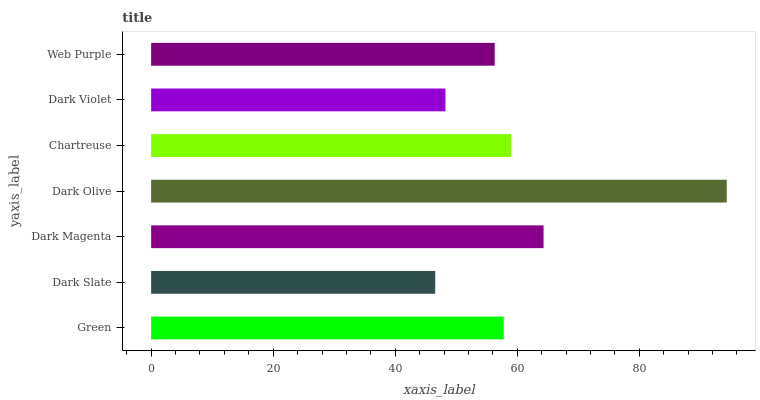Is Dark Slate the minimum?
Answer yes or no. Yes. Is Dark Olive the maximum?
Answer yes or no. Yes. Is Dark Magenta the minimum?
Answer yes or no. No. Is Dark Magenta the maximum?
Answer yes or no. No. Is Dark Magenta greater than Dark Slate?
Answer yes or no. Yes. Is Dark Slate less than Dark Magenta?
Answer yes or no. Yes. Is Dark Slate greater than Dark Magenta?
Answer yes or no. No. Is Dark Magenta less than Dark Slate?
Answer yes or no. No. Is Green the high median?
Answer yes or no. Yes. Is Green the low median?
Answer yes or no. Yes. Is Dark Violet the high median?
Answer yes or no. No. Is Web Purple the low median?
Answer yes or no. No. 